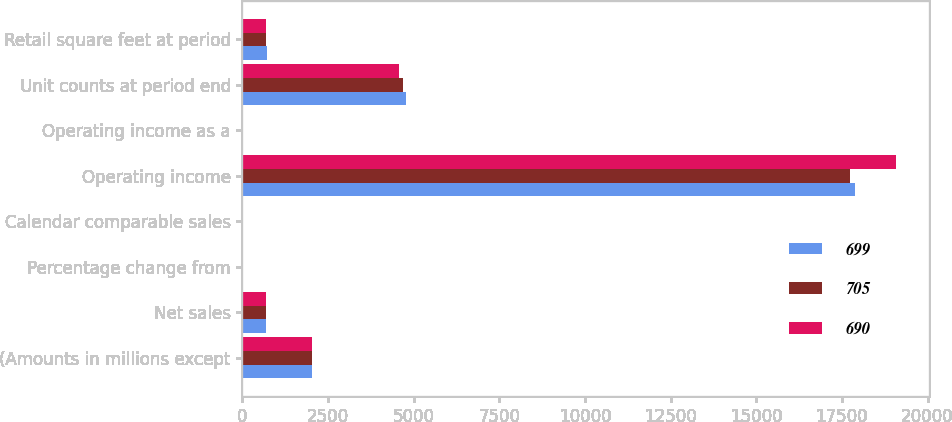<chart> <loc_0><loc_0><loc_500><loc_500><stacked_bar_chart><ecel><fcel>(Amounts in millions except<fcel>Net sales<fcel>Percentage change from<fcel>Calendar comparable sales<fcel>Operating income<fcel>Operating income as a<fcel>Unit counts at period end<fcel>Retail square feet at period<nl><fcel>699<fcel>2018<fcel>699<fcel>3.5<fcel>2.1<fcel>17869<fcel>5.6<fcel>4761<fcel>705<nl><fcel>705<fcel>2017<fcel>699<fcel>3.2<fcel>1.6<fcel>17745<fcel>5.8<fcel>4672<fcel>699<nl><fcel>690<fcel>2016<fcel>699<fcel>3.6<fcel>1<fcel>19087<fcel>6.4<fcel>4574<fcel>690<nl></chart> 